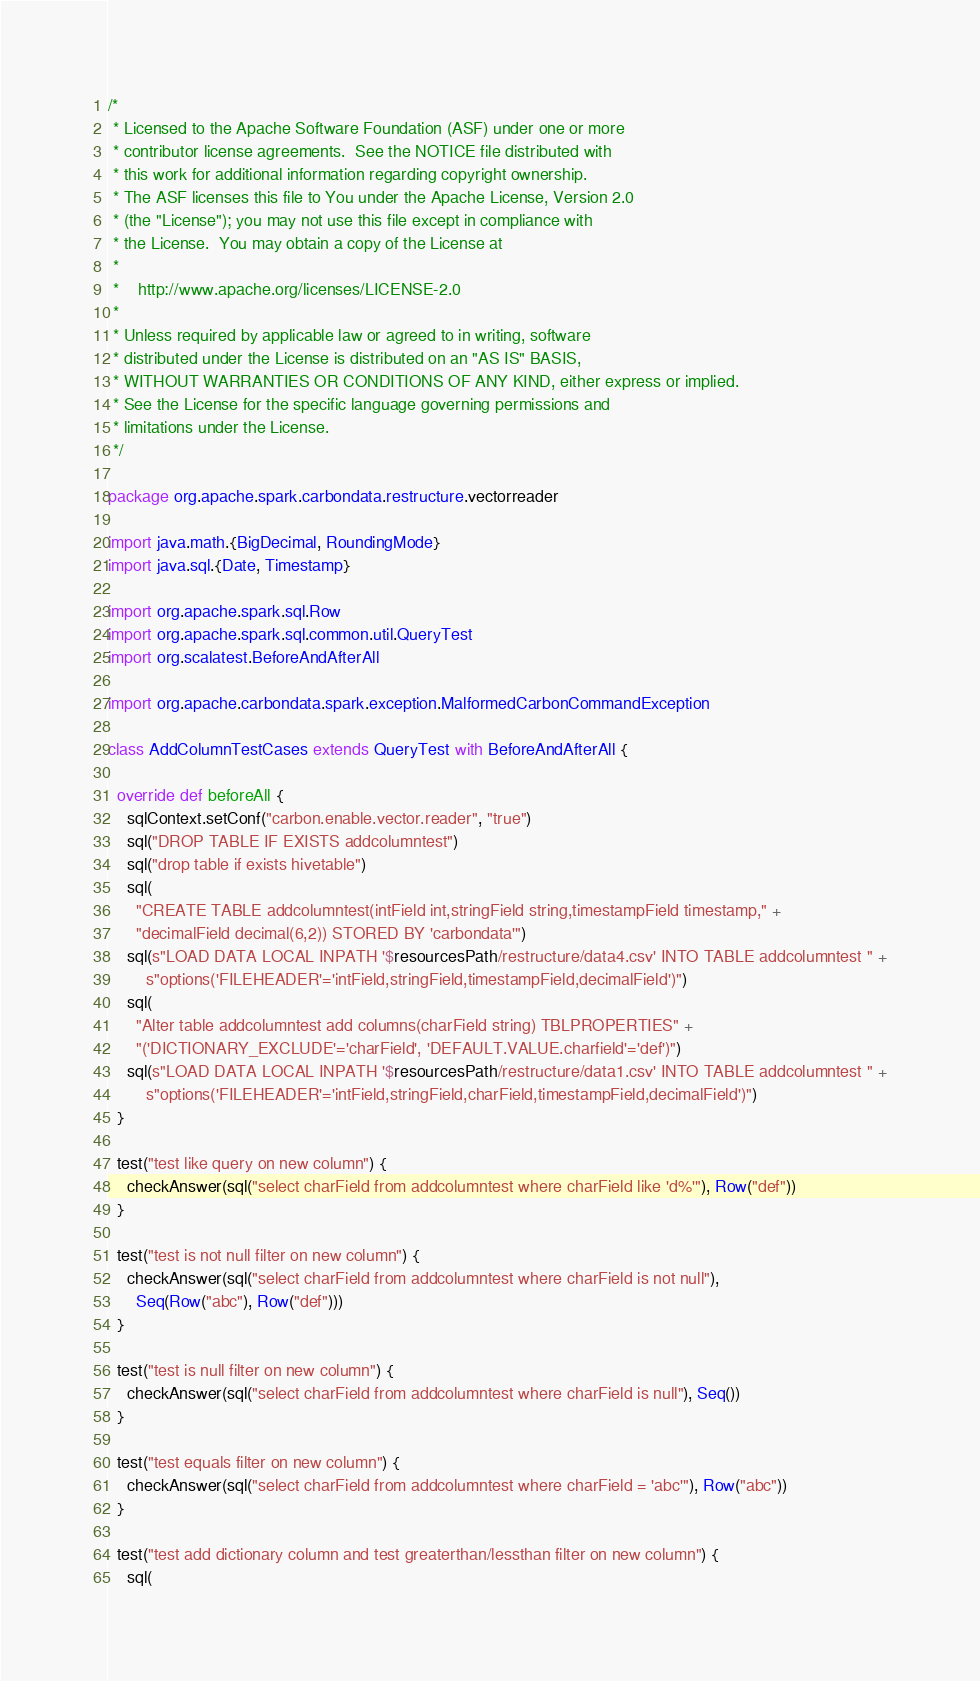<code> <loc_0><loc_0><loc_500><loc_500><_Scala_>/*
 * Licensed to the Apache Software Foundation (ASF) under one or more
 * contributor license agreements.  See the NOTICE file distributed with
 * this work for additional information regarding copyright ownership.
 * The ASF licenses this file to You under the Apache License, Version 2.0
 * (the "License"); you may not use this file except in compliance with
 * the License.  You may obtain a copy of the License at
 *
 *    http://www.apache.org/licenses/LICENSE-2.0
 *
 * Unless required by applicable law or agreed to in writing, software
 * distributed under the License is distributed on an "AS IS" BASIS,
 * WITHOUT WARRANTIES OR CONDITIONS OF ANY KIND, either express or implied.
 * See the License for the specific language governing permissions and
 * limitations under the License.
 */

package org.apache.spark.carbondata.restructure.vectorreader

import java.math.{BigDecimal, RoundingMode}
import java.sql.{Date, Timestamp}

import org.apache.spark.sql.Row
import org.apache.spark.sql.common.util.QueryTest
import org.scalatest.BeforeAndAfterAll

import org.apache.carbondata.spark.exception.MalformedCarbonCommandException

class AddColumnTestCases extends QueryTest with BeforeAndAfterAll {

  override def beforeAll {
    sqlContext.setConf("carbon.enable.vector.reader", "true")
    sql("DROP TABLE IF EXISTS addcolumntest")
    sql("drop table if exists hivetable")
    sql(
      "CREATE TABLE addcolumntest(intField int,stringField string,timestampField timestamp," +
      "decimalField decimal(6,2)) STORED BY 'carbondata'")
    sql(s"LOAD DATA LOCAL INPATH '$resourcesPath/restructure/data4.csv' INTO TABLE addcolumntest " +
        s"options('FILEHEADER'='intField,stringField,timestampField,decimalField')")
    sql(
      "Alter table addcolumntest add columns(charField string) TBLPROPERTIES" +
      "('DICTIONARY_EXCLUDE'='charField', 'DEFAULT.VALUE.charfield'='def')")
    sql(s"LOAD DATA LOCAL INPATH '$resourcesPath/restructure/data1.csv' INTO TABLE addcolumntest " +
        s"options('FILEHEADER'='intField,stringField,charField,timestampField,decimalField')")
  }

  test("test like query on new column") {
    checkAnswer(sql("select charField from addcolumntest where charField like 'd%'"), Row("def"))
  }

  test("test is not null filter on new column") {
    checkAnswer(sql("select charField from addcolumntest where charField is not null"),
      Seq(Row("abc"), Row("def")))
  }

  test("test is null filter on new column") {
    checkAnswer(sql("select charField from addcolumntest where charField is null"), Seq())
  }

  test("test equals filter on new column") {
    checkAnswer(sql("select charField from addcolumntest where charField = 'abc'"), Row("abc"))
  }

  test("test add dictionary column and test greaterthan/lessthan filter on new column") {
    sql(</code> 